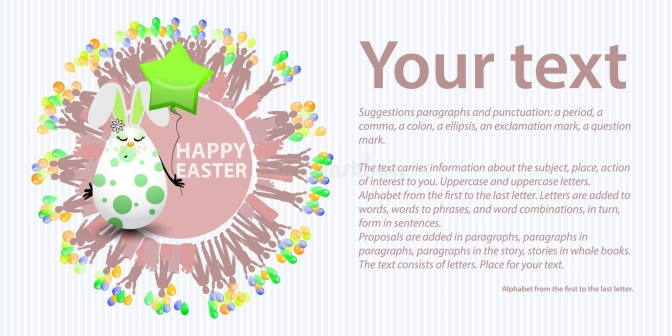What kind of event do you think this image is promoting? The image seems to be promoting an Easter celebration. The whimsical Easter bunny adorned with colorful spots, holding a green star balloon, and the burst of confetti suggest a festive and playful event. Additionally, the text burst behind the bunny reading "HAPPY EASTER" further emphasizes the Easter theme. The customizable text box on the right also indicates that this image could be used to promote various Easter-related events, such as a community Easter egg hunt, a family gathering, or an Easter-themed party. 